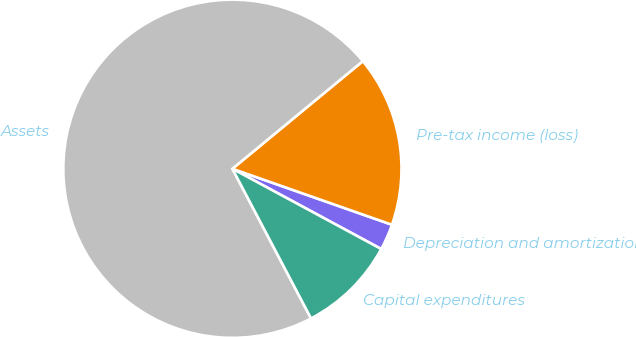Convert chart. <chart><loc_0><loc_0><loc_500><loc_500><pie_chart><fcel>Depreciation and amortization<fcel>Pre-tax income (loss)<fcel>Assets<fcel>Capital expenditures<nl><fcel>2.5%<fcel>16.35%<fcel>71.72%<fcel>9.43%<nl></chart> 